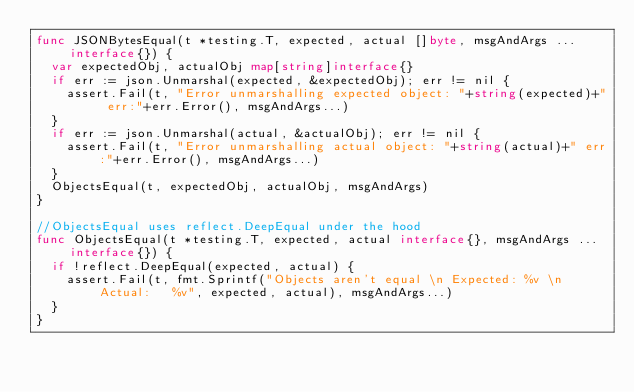<code> <loc_0><loc_0><loc_500><loc_500><_Go_>func JSONBytesEqual(t *testing.T, expected, actual []byte, msgAndArgs ...interface{}) {
	var expectedObj, actualObj map[string]interface{}
	if err := json.Unmarshal(expected, &expectedObj); err != nil {
		assert.Fail(t, "Error unmarshalling expected object: "+string(expected)+" err:"+err.Error(), msgAndArgs...)
	}
	if err := json.Unmarshal(actual, &actualObj); err != nil {
		assert.Fail(t, "Error unmarshalling actual object: "+string(actual)+" err:"+err.Error(), msgAndArgs...)
	}
	ObjectsEqual(t, expectedObj, actualObj, msgAndArgs)
}

//ObjectsEqual uses reflect.DeepEqual under the hood
func ObjectsEqual(t *testing.T, expected, actual interface{}, msgAndArgs ...interface{}) {
	if !reflect.DeepEqual(expected, actual) {
		assert.Fail(t, fmt.Sprintf("Objects aren't equal \n Expected: %v \n Actual:   %v", expected, actual), msgAndArgs...)
	}
}
</code> 